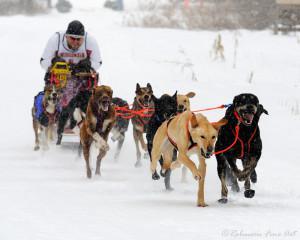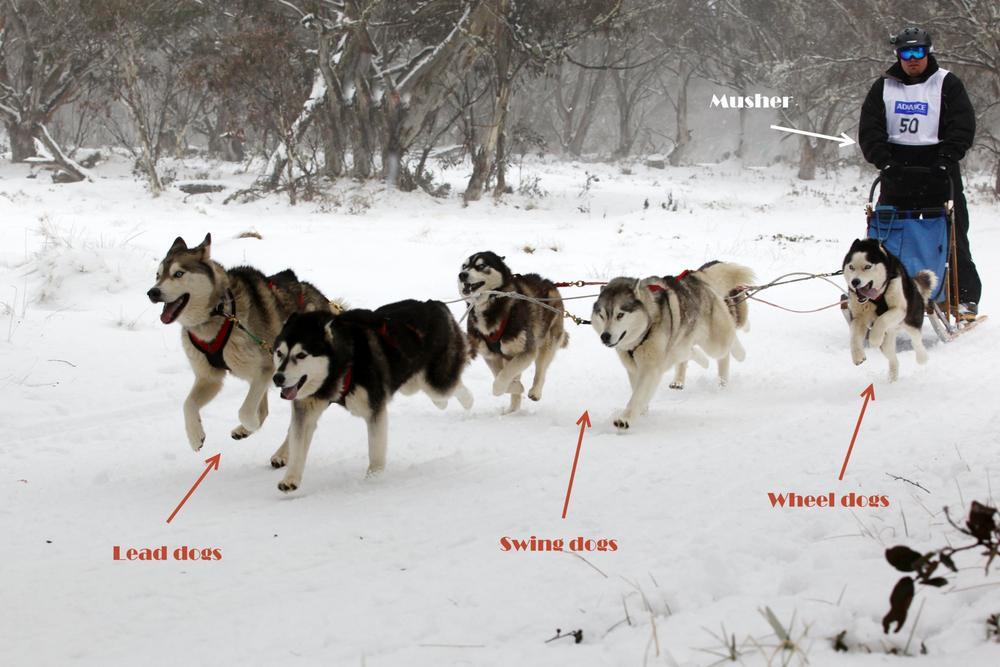The first image is the image on the left, the second image is the image on the right. For the images displayed, is the sentence "None of the dogs are wearing gloves." factually correct? Answer yes or no. Yes. 